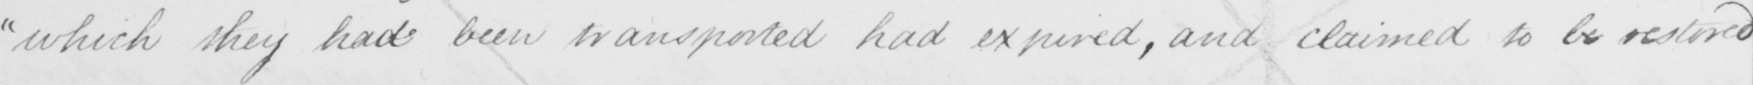What text is written in this handwritten line? which they had been transported had expired , and claimed to be restored 